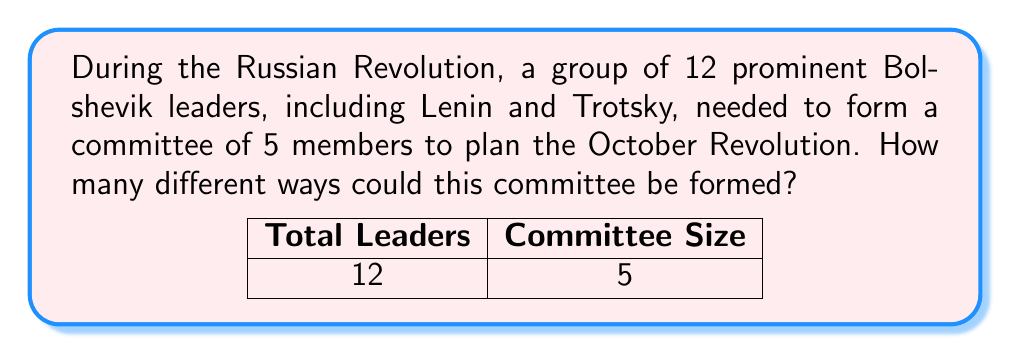Help me with this question. Let's approach this step-by-step:

1) This is a combination problem. We are selecting 5 people from a group of 12, where the order doesn't matter (it's the same committee regardless of the order in which members are chosen).

2) The formula for combinations is:

   $$C(n,r) = \frac{n!}{r!(n-r)!}$$

   Where $n$ is the total number of items to choose from, and $r$ is the number of items being chosen.

3) In this case, $n = 12$ (total Bolshevik leaders) and $r = 5$ (committee size).

4) Plugging these numbers into our formula:

   $$C(12,5) = \frac{12!}{5!(12-5)!} = \frac{12!}{5!7!}$$

5) Expanding this:
   
   $$\frac{12 \times 11 \times 10 \times 9 \times 8 \times 7!}{(5 \times 4 \times 3 \times 2 \times 1) \times 7!}$$

6) The $7!$ cancels out in the numerator and denominator:

   $$\frac{12 \times 11 \times 10 \times 9 \times 8}{5 \times 4 \times 3 \times 2 \times 1}$$

7) Multiplying the numerator and denominator:

   $$\frac{95,040}{120} = 792$$

Therefore, there are 792 different ways to form the committee.
Answer: 792 